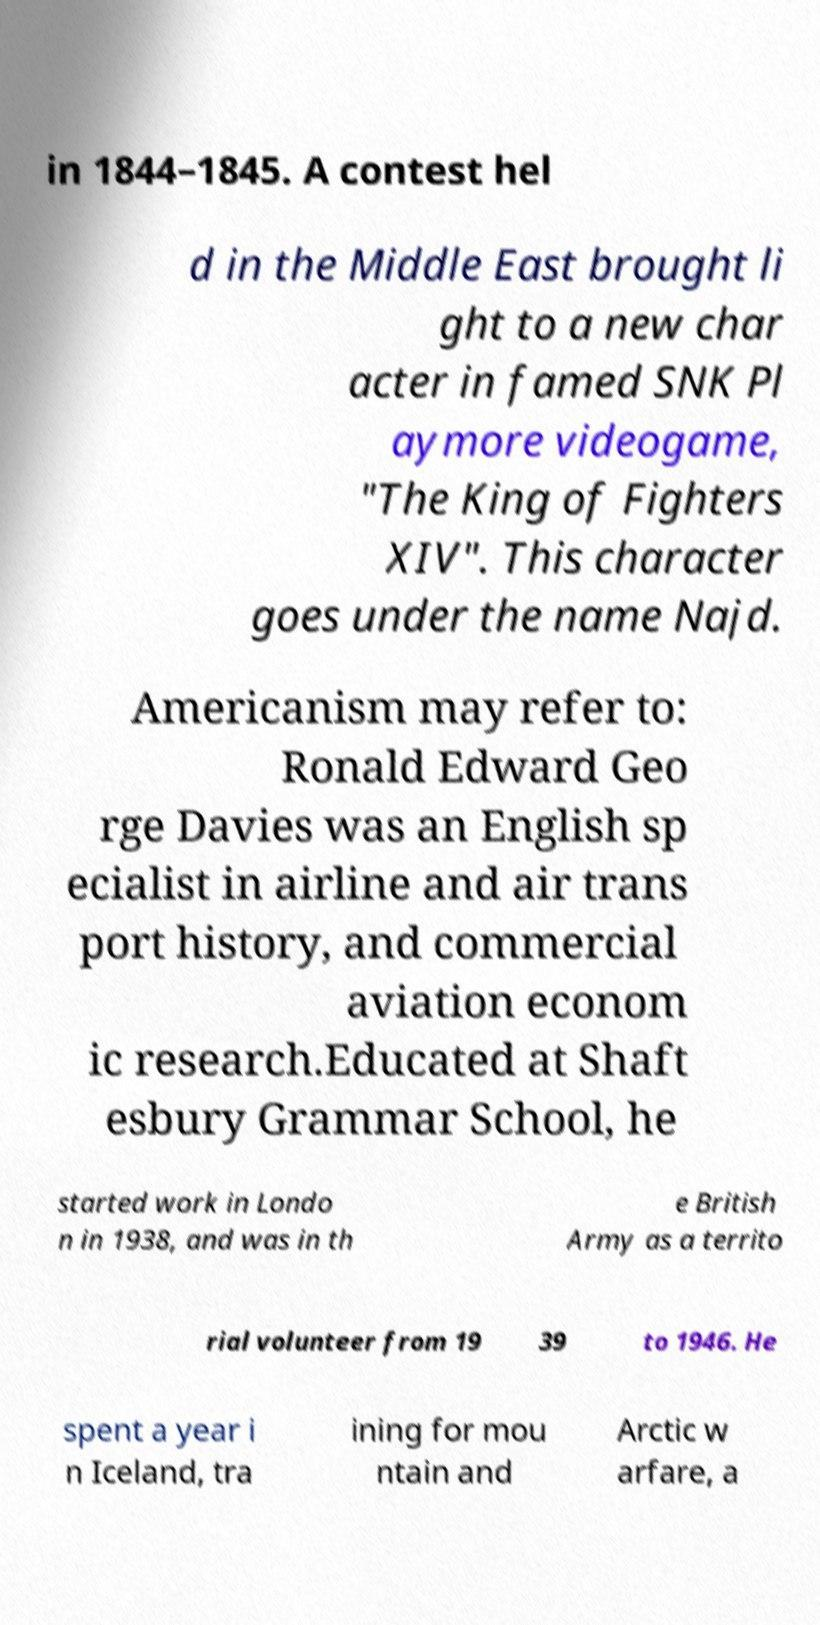Please identify and transcribe the text found in this image. in 1844–1845. A contest hel d in the Middle East brought li ght to a new char acter in famed SNK Pl aymore videogame, "The King of Fighters XIV". This character goes under the name Najd. Americanism may refer to: Ronald Edward Geo rge Davies was an English sp ecialist in airline and air trans port history, and commercial aviation econom ic research.Educated at Shaft esbury Grammar School, he started work in Londo n in 1938, and was in th e British Army as a territo rial volunteer from 19 39 to 1946. He spent a year i n Iceland, tra ining for mou ntain and Arctic w arfare, a 